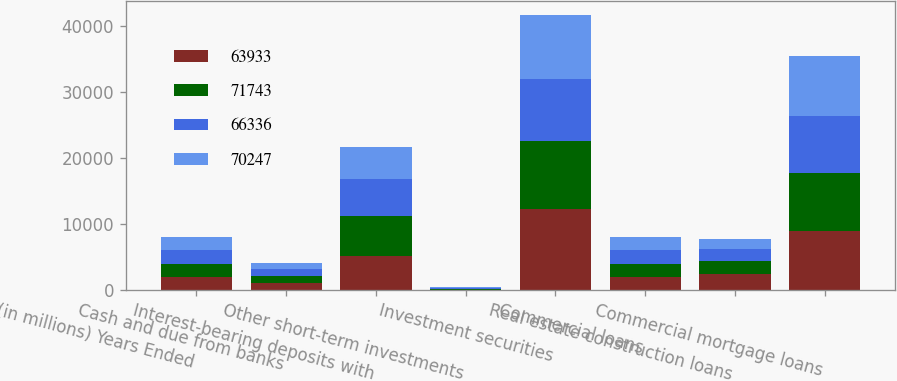Convert chart to OTSL. <chart><loc_0><loc_0><loc_500><loc_500><stacked_bar_chart><ecel><fcel>(in millions) Years Ended<fcel>Cash and due from banks<fcel>Interest-bearing deposits with<fcel>Other short-term investments<fcel>Investment securities<fcel>Commercial loans<fcel>Real estate construction loans<fcel>Commercial mortgage loans<nl><fcel>63933<fcel>2016<fcel>1146<fcel>5099<fcel>102<fcel>12348<fcel>2015.5<fcel>2508<fcel>8981<nl><fcel>71743<fcel>2015<fcel>1059<fcel>6158<fcel>106<fcel>10237<fcel>2015.5<fcel>1884<fcel>8697<nl><fcel>66336<fcel>2014<fcel>934<fcel>5513<fcel>109<fcel>9350<fcel>2015.5<fcel>1909<fcel>8706<nl><fcel>70247<fcel>2013<fcel>987<fcel>4930<fcel>112<fcel>9637<fcel>2015.5<fcel>1486<fcel>9060<nl></chart> 